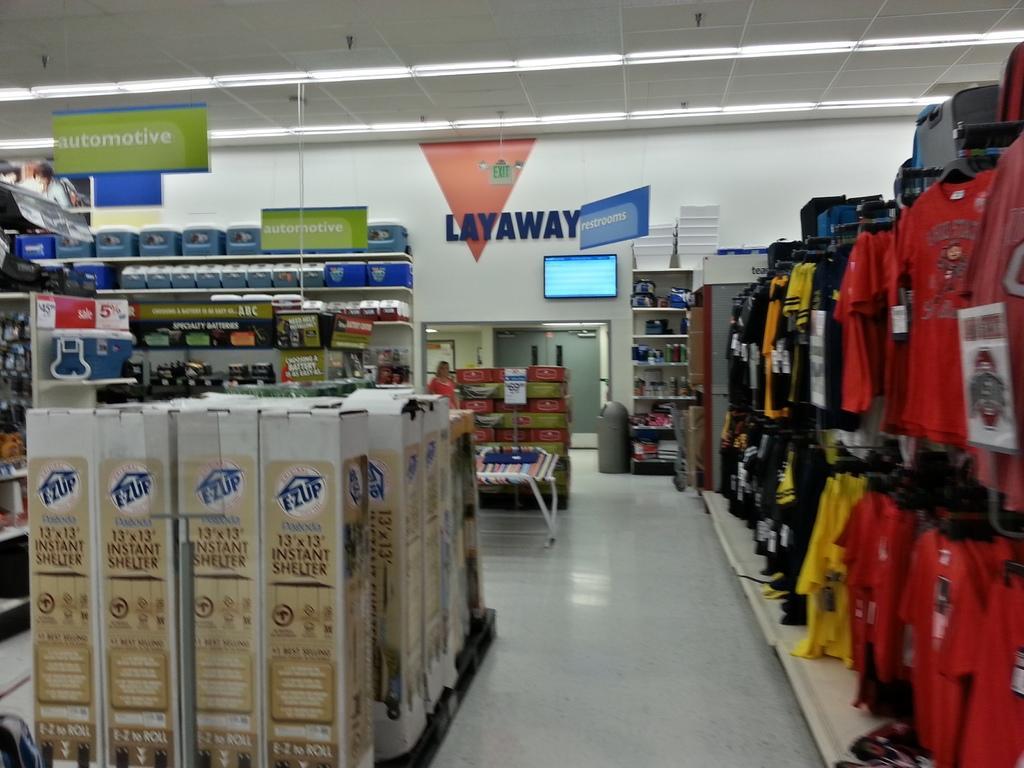Describe this image in one or two sentences. In this image we can see a store. In the store there are clothes hanged to the hangers, cartons, name boards, trolleys, person, display screen, bins and walls. 